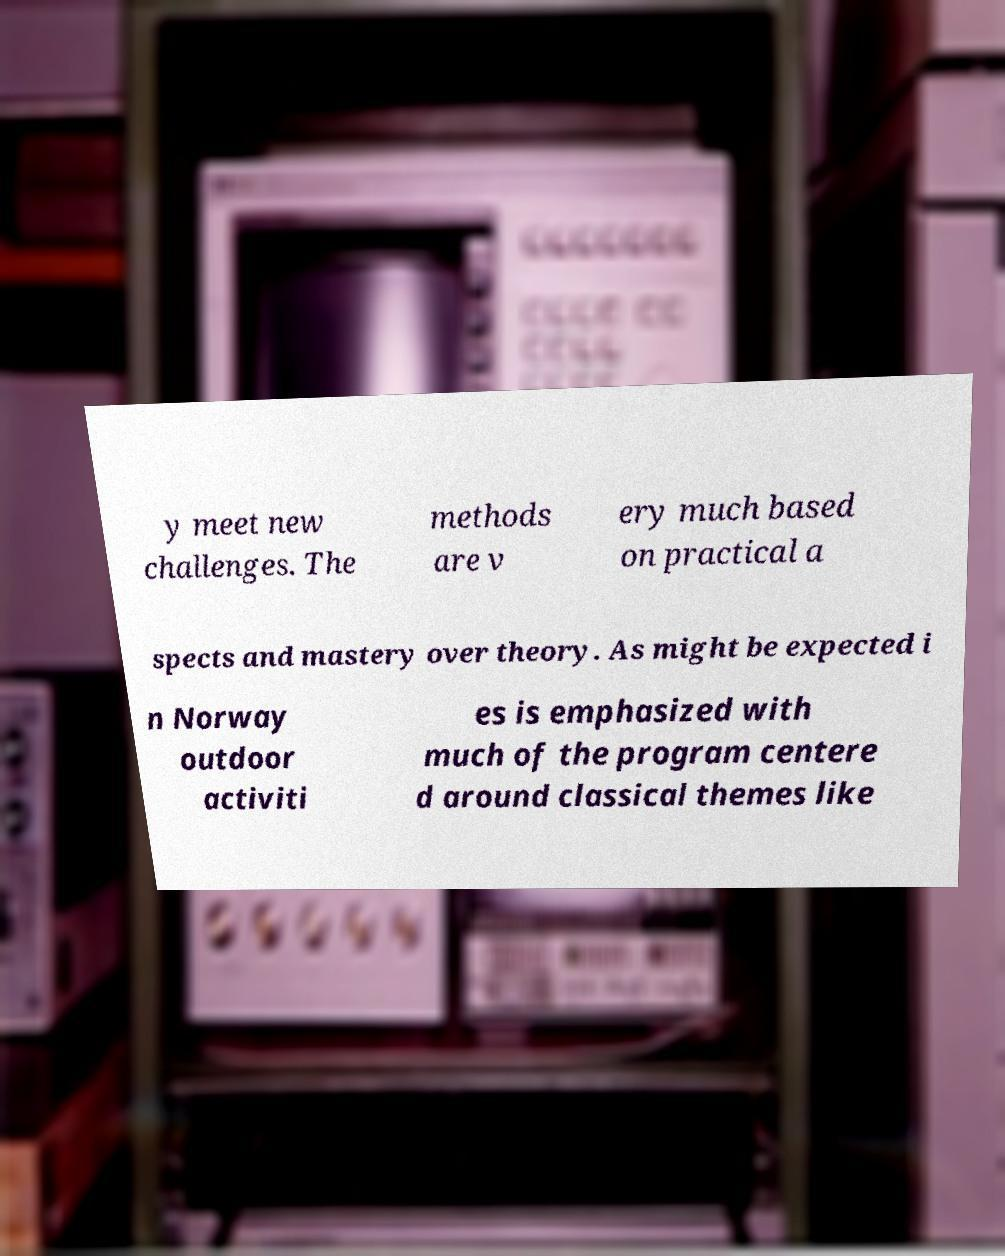Could you extract and type out the text from this image? y meet new challenges. The methods are v ery much based on practical a spects and mastery over theory. As might be expected i n Norway outdoor activiti es is emphasized with much of the program centere d around classical themes like 